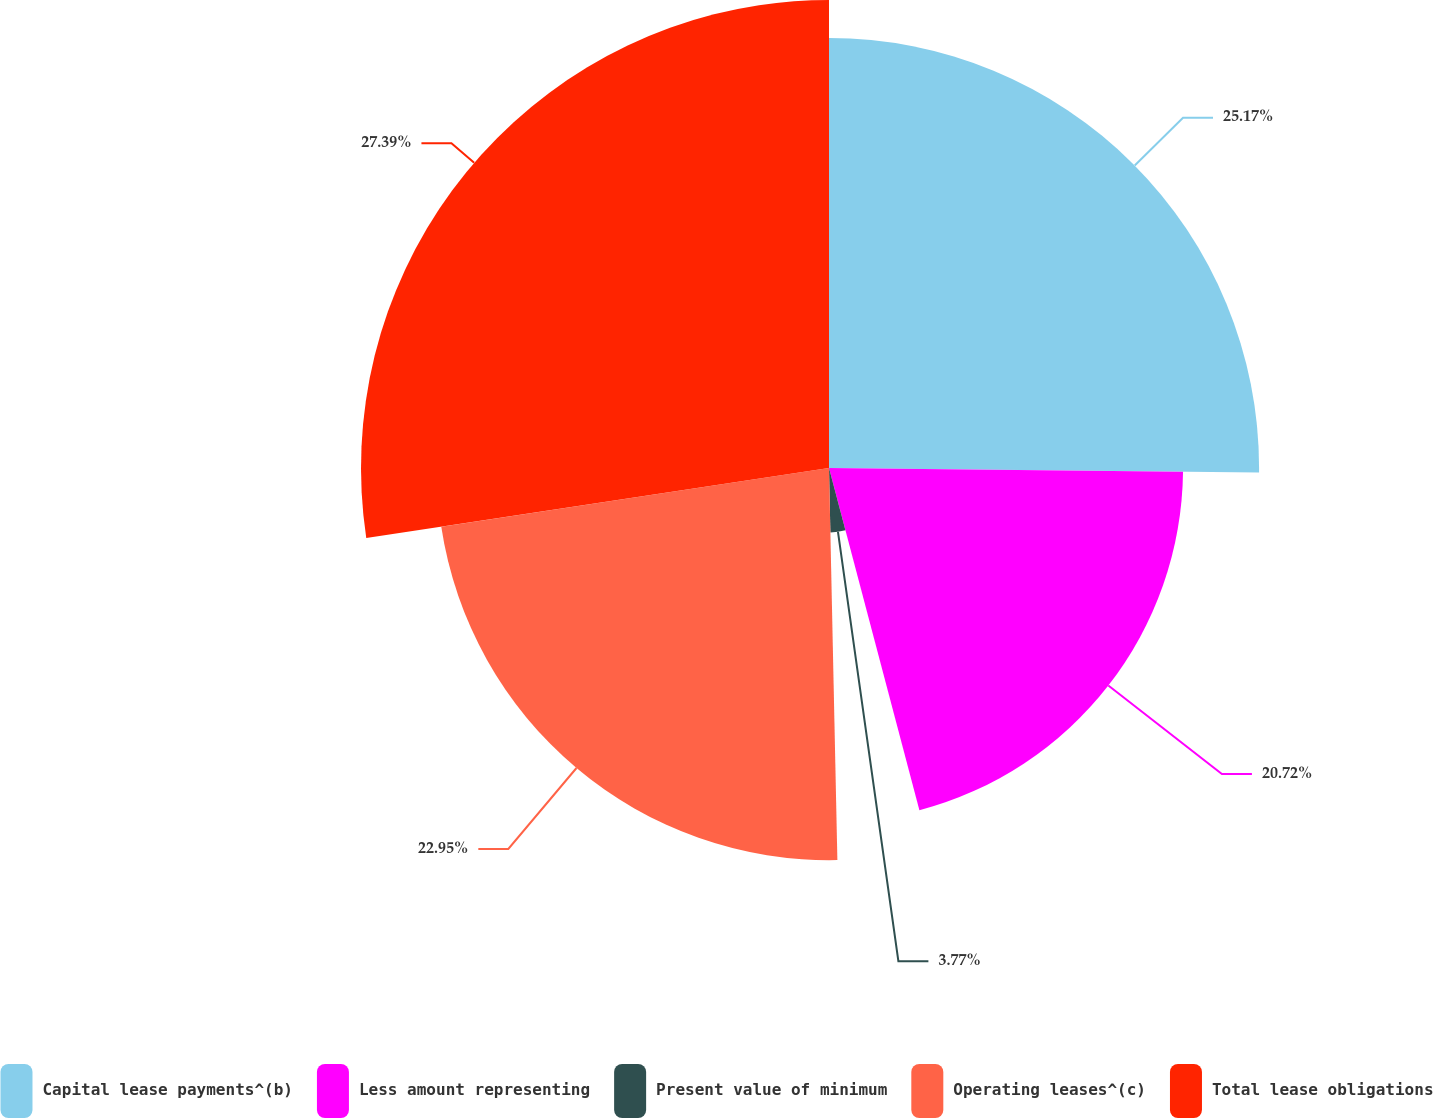Convert chart. <chart><loc_0><loc_0><loc_500><loc_500><pie_chart><fcel>Capital lease payments^(b)<fcel>Less amount representing<fcel>Present value of minimum<fcel>Operating leases^(c)<fcel>Total lease obligations<nl><fcel>25.17%<fcel>20.72%<fcel>3.77%<fcel>22.95%<fcel>27.39%<nl></chart> 